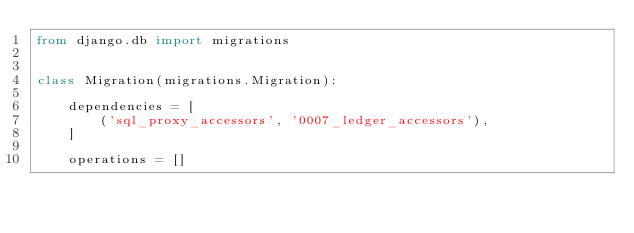<code> <loc_0><loc_0><loc_500><loc_500><_Python_>from django.db import migrations


class Migration(migrations.Migration):

    dependencies = [
        ('sql_proxy_accessors', '0007_ledger_accessors'),
    ]

    operations = []
</code> 